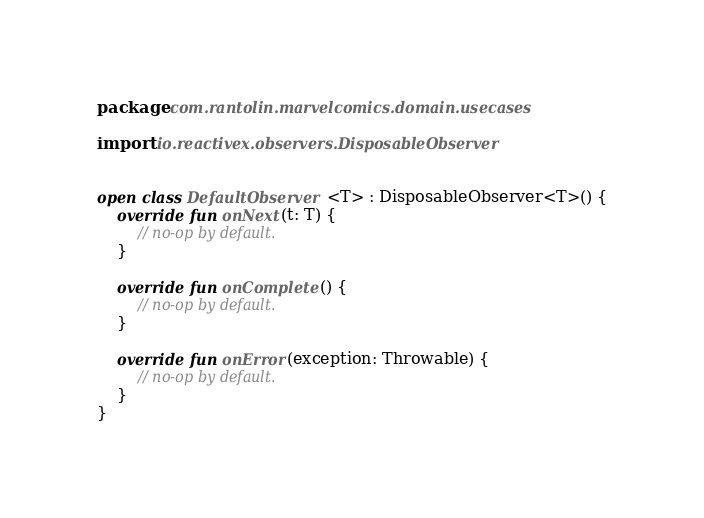<code> <loc_0><loc_0><loc_500><loc_500><_Kotlin_>package com.rantolin.marvelcomics.domain.usecases

import io.reactivex.observers.DisposableObserver


open class DefaultObserver <T> : DisposableObserver<T>() {
    override fun onNext(t: T) {
        // no-op by default.
    }

    override fun onComplete() {
        // no-op by default.
    }

    override fun onError(exception: Throwable) {
        // no-op by default.
    }
}</code> 